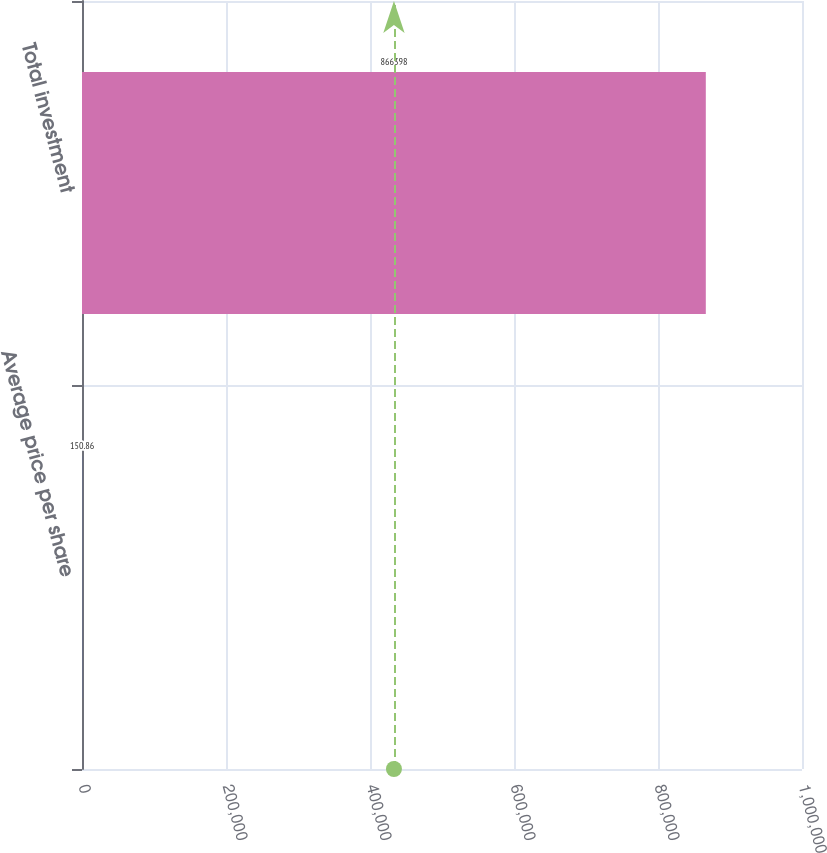Convert chart. <chart><loc_0><loc_0><loc_500><loc_500><bar_chart><fcel>Average price per share<fcel>Total investment<nl><fcel>150.86<fcel>866398<nl></chart> 